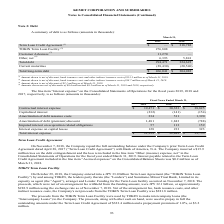According to Kemet Corporation's financial document, What was the Contractual interest expense in 2017? According to the financial document, 38,825 (in thousands). The relevant text states: "Contractual interest expense $ 19,471 $ 30,323 $ 38,825..." Also, What was the Capitalized interest in 2019? According to the financial document, (232) (in thousands). The relevant text states: "Capitalized interest (232) (141) (154)..." Also, What was the Interest expense on capital leases in 2018? According to the financial document, 233 (in thousands). The relevant text states: "Interest expense on capital leases 128 233 323..." Also, can you calculate: What was the change in the Amortization of debt issuance costs between 2017 and 2018? Based on the calculation: 511-1,390, the result is -879 (in thousands). This is based on the information: "Amortization of debt issuance costs 334 511 1,390 Amortization of debt issuance costs 334 511 1,390..." The key data points involved are: 1,390, 511. Also, How many years did Interest expense on capital leases exceed $200 thousand? Counting the relevant items in the document: 2018, 2017, I find 2 instances. The key data points involved are: 2017, 2018. Also, can you calculate: What was the percentage change in the total interest expense between 2018 and 2019? To answer this question, I need to perform calculations using the financial data. The calculation is: (21,239-32,882)/32,882, which equals -35.41 (percentage). This is based on the information: "Total interest expense $ 21,239 $ 32,882 $ 39,755 Total interest expense $ 21,239 $ 32,882 $ 39,755..." The key data points involved are: 21,239, 32,882. 